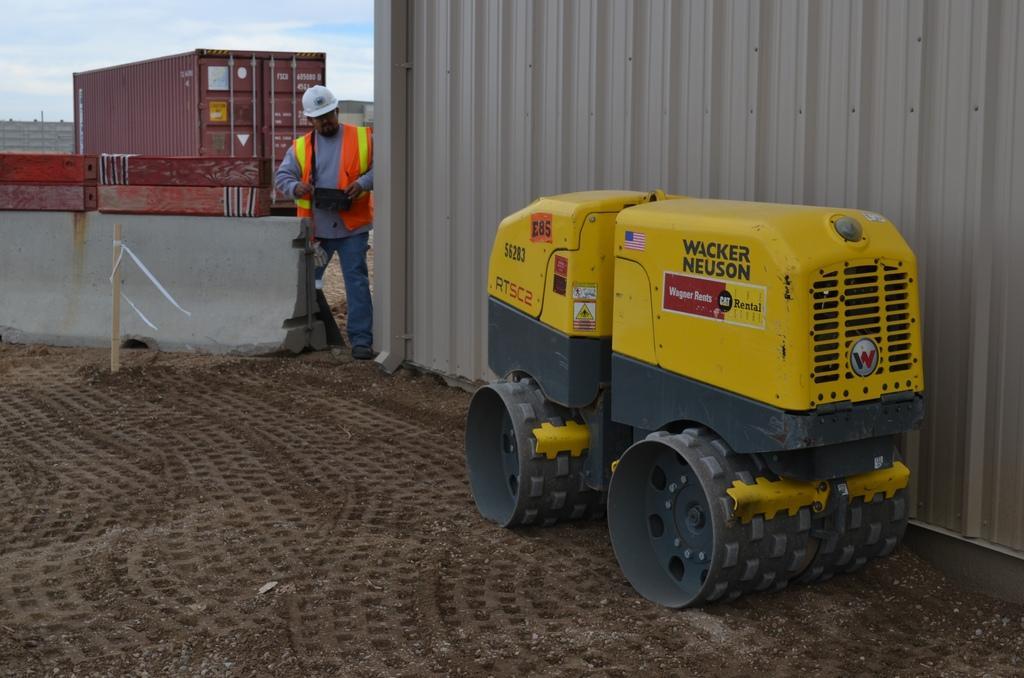Describe this image in one or two sentences. In this image, we can see a vehicle on the ground. Background we can see few containers, pole, some object. Here a person is holding a block device and wearing a helmet. Left side top of the image, we can see the sky. 